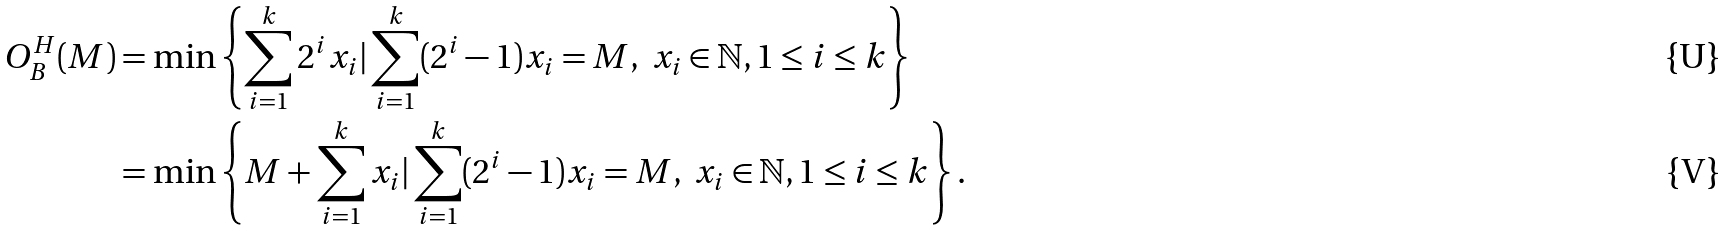<formula> <loc_0><loc_0><loc_500><loc_500>O _ { B } ^ { H } ( M ) & = \min \left \{ \sum _ { i = 1 } ^ { k } 2 ^ { i } x _ { i } | \sum _ { i = 1 } ^ { k } ( 2 ^ { i } - 1 ) x _ { i } = M , \ x _ { i } \in \mathbb { N } , 1 \leq i \leq k \right \} \\ & = \min \left \{ M + \sum _ { i = 1 } ^ { k } x _ { i } | \sum _ { i = 1 } ^ { k } ( 2 ^ { i } - 1 ) x _ { i } = M , \ x _ { i } \in \mathbb { N } , 1 \leq i \leq k \right \} .</formula> 